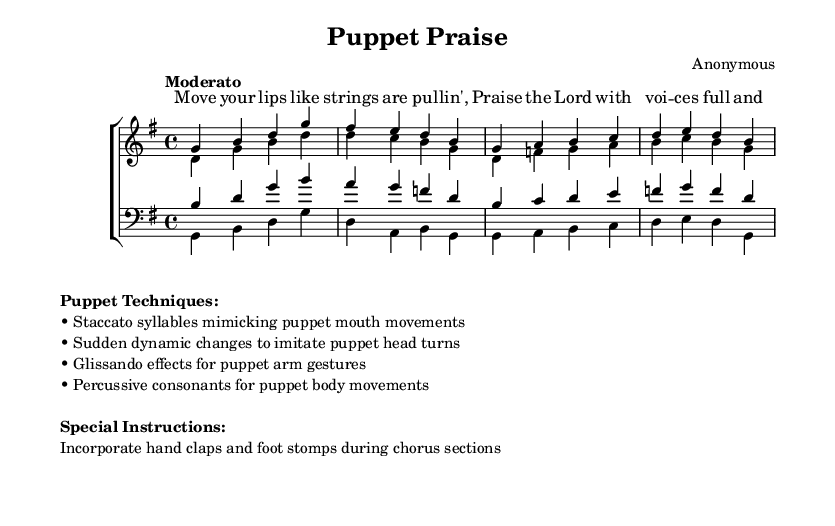What is the key signature of this music? The key signature is G major, which has one sharp (F#).
Answer: G major What is the time signature of this music? The time signature is 4/4, indicating four beats per measure.
Answer: 4/4 What tempo marking is indicated in the score? The tempo marking is "Moderato," which suggests a moderate speed of performance.
Answer: Moderato How many vocal parts are present in this piece? There are four vocal parts: sopranos, altos, tenors, and basses.
Answer: Four What special instructions are provided for the performance? The special instructions include incorporating hand claps and foot stomps during chorus sections.
Answer: Hand claps and foot stomps What techniques are suggested for mimicking puppet movements in singing? Techniques include staccato syllables, sudden dynamic changes, glissando effects, and percussive consonants.
Answer: Staccato, dynamic changes, glissando, percussive consonants What lyrical theme is expressed in the verse? The lyrical theme expresses praise and mimics the movement of strings, emphasizing vocal expression.
Answer: Praise and vocal movement 